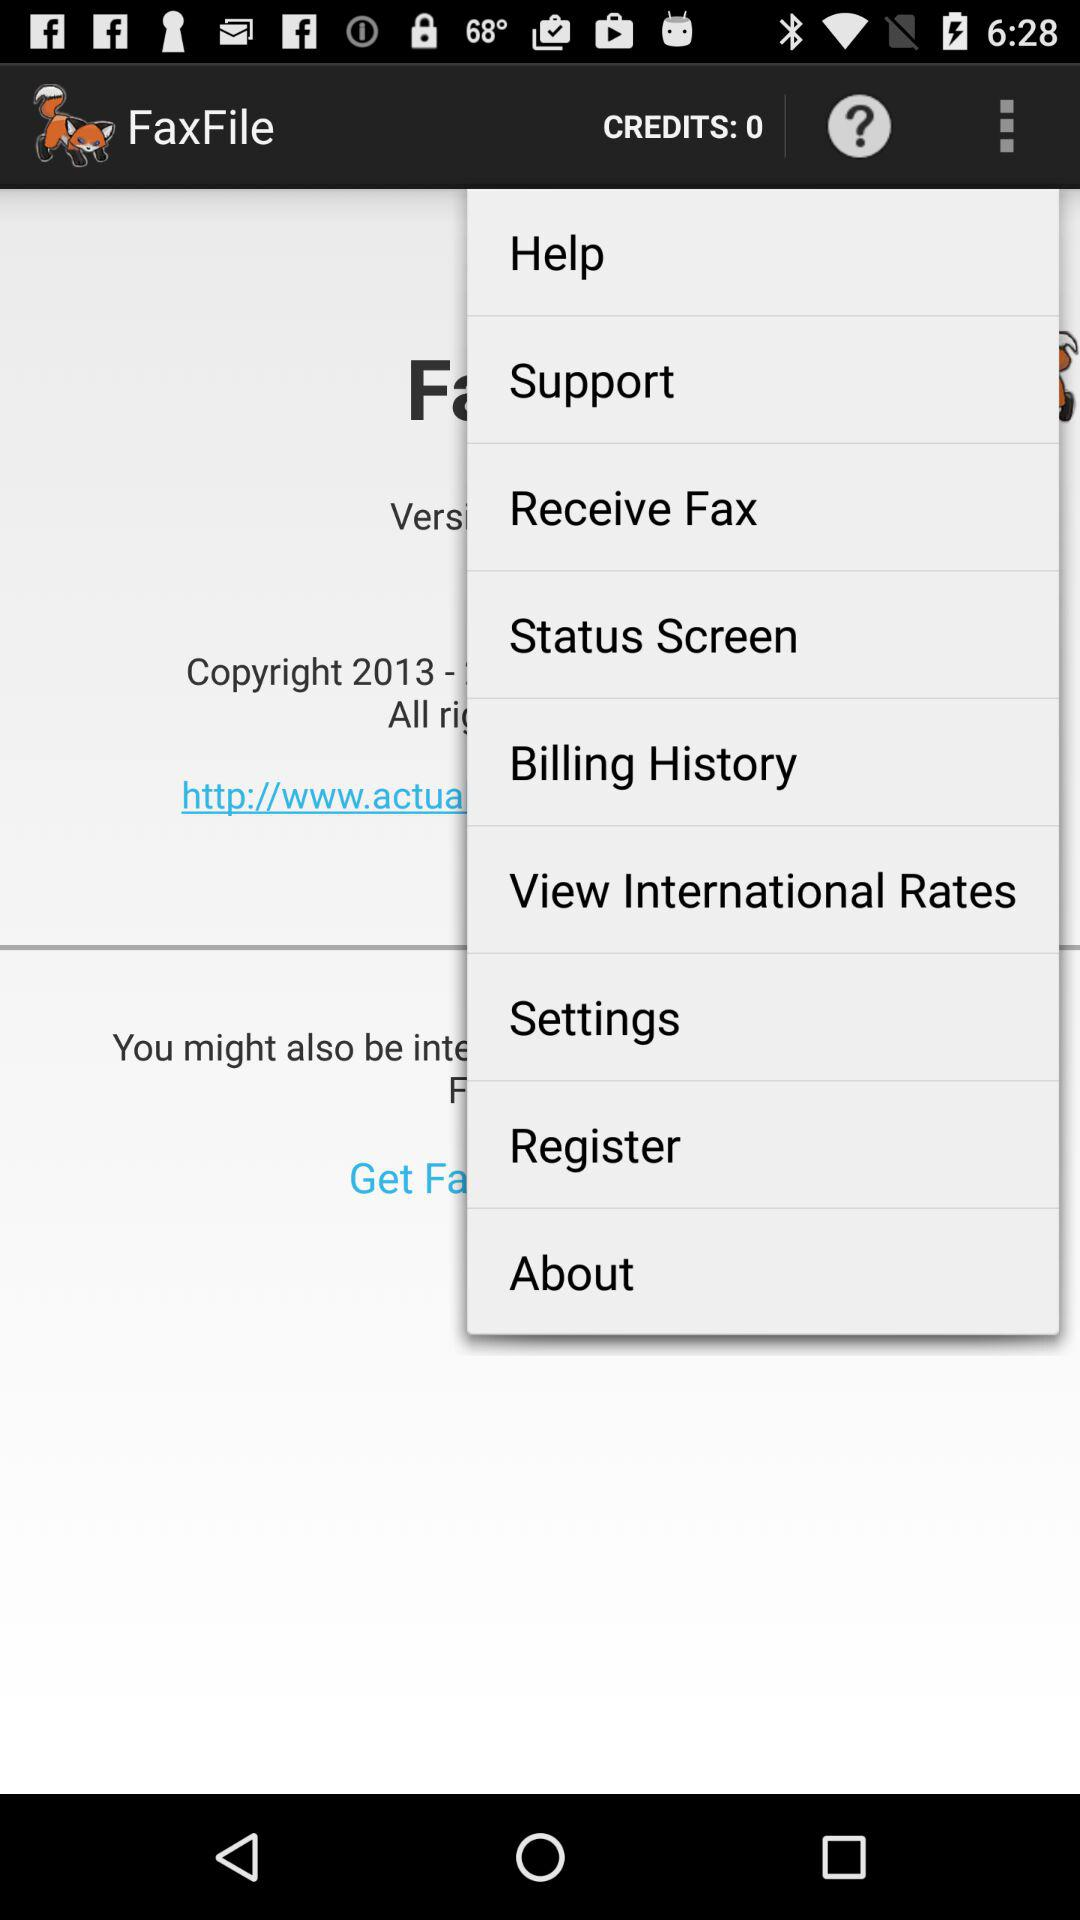How many credits are there? There are 0 credits. 